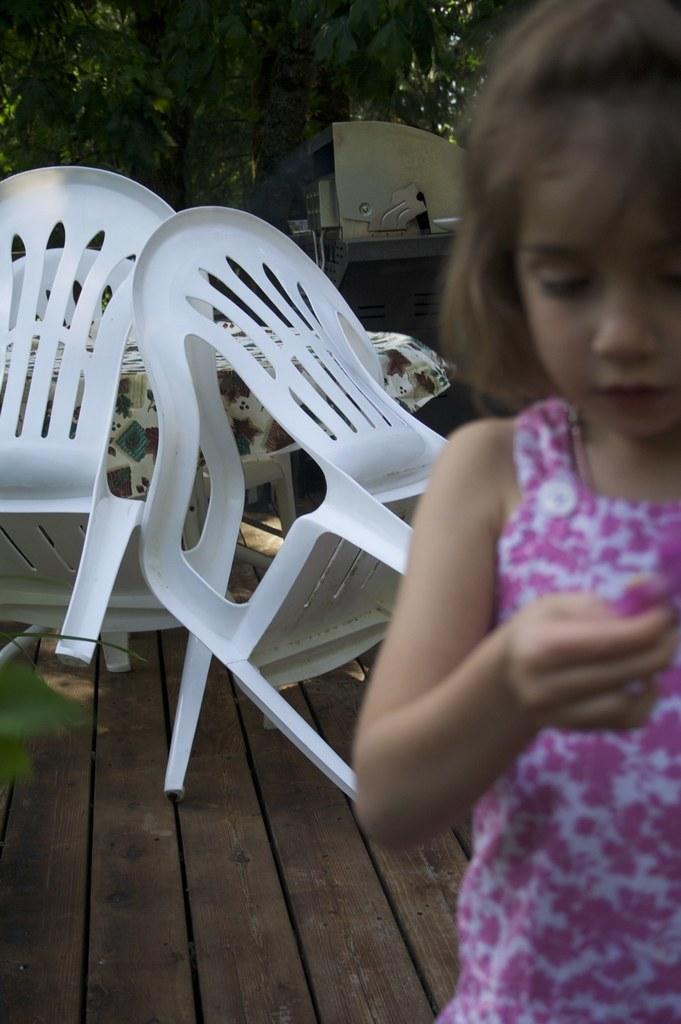How would you summarize this image in a sentence or two? Here in the right side we can see a girl and behind her we can see a couple of chairs and table present and there are also trees present 